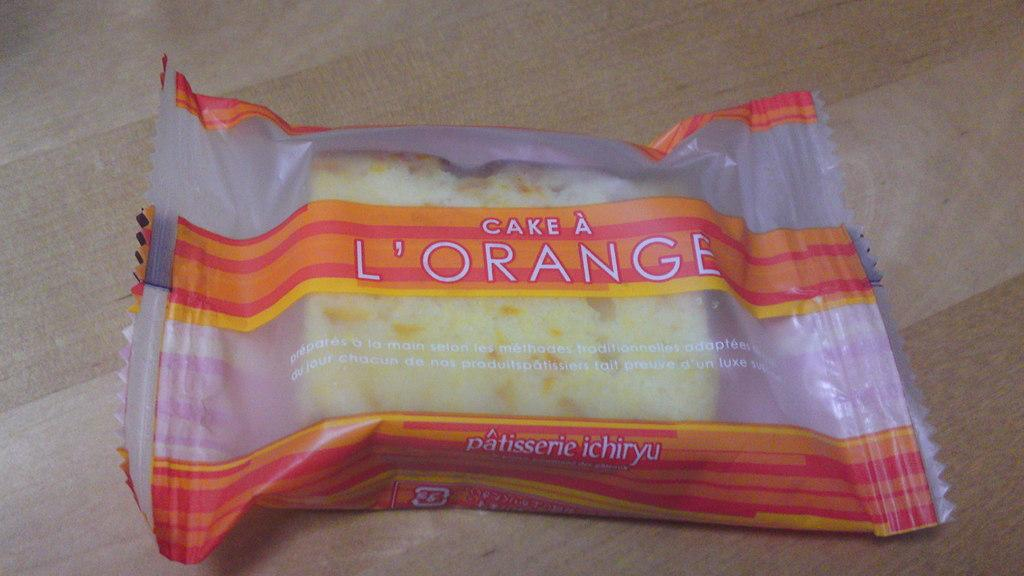What is the main subject of the image? There is a cake in the image. How is the cake protected or covered? The cake is covered with a plastic cover. What color is the cake? The cake is in cream color. What is the color of the surface the cake is placed on? The cake is on a brown surface. Is there a wound visible on the cake in the image? No, there is no wound visible on the cake in the image. 